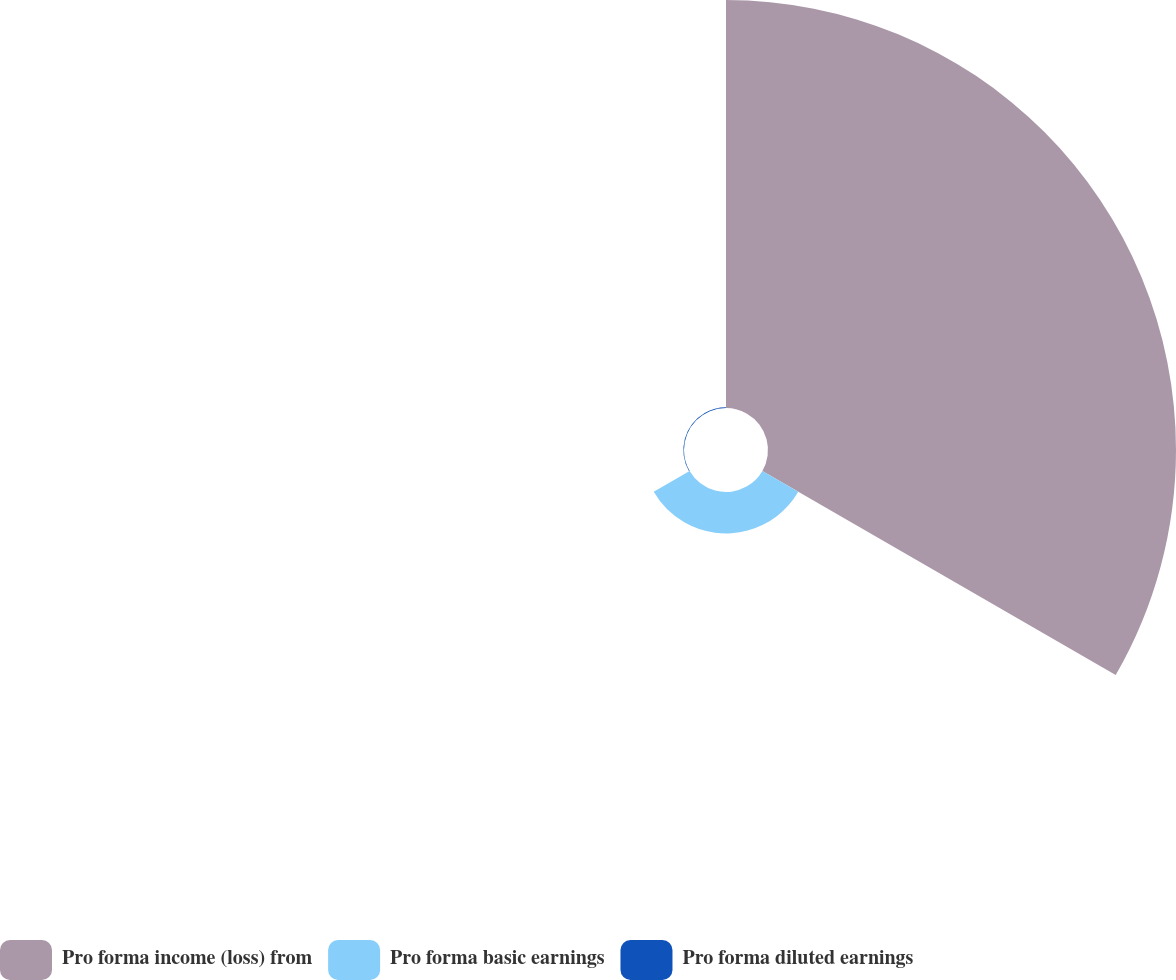Convert chart. <chart><loc_0><loc_0><loc_500><loc_500><pie_chart><fcel>Pro forma income (loss) from<fcel>Pro forma basic earnings<fcel>Pro forma diluted earnings<nl><fcel>90.64%<fcel>9.2%<fcel>0.15%<nl></chart> 